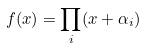<formula> <loc_0><loc_0><loc_500><loc_500>f ( x ) = \prod _ { i } ( x + \alpha _ { i } )</formula> 